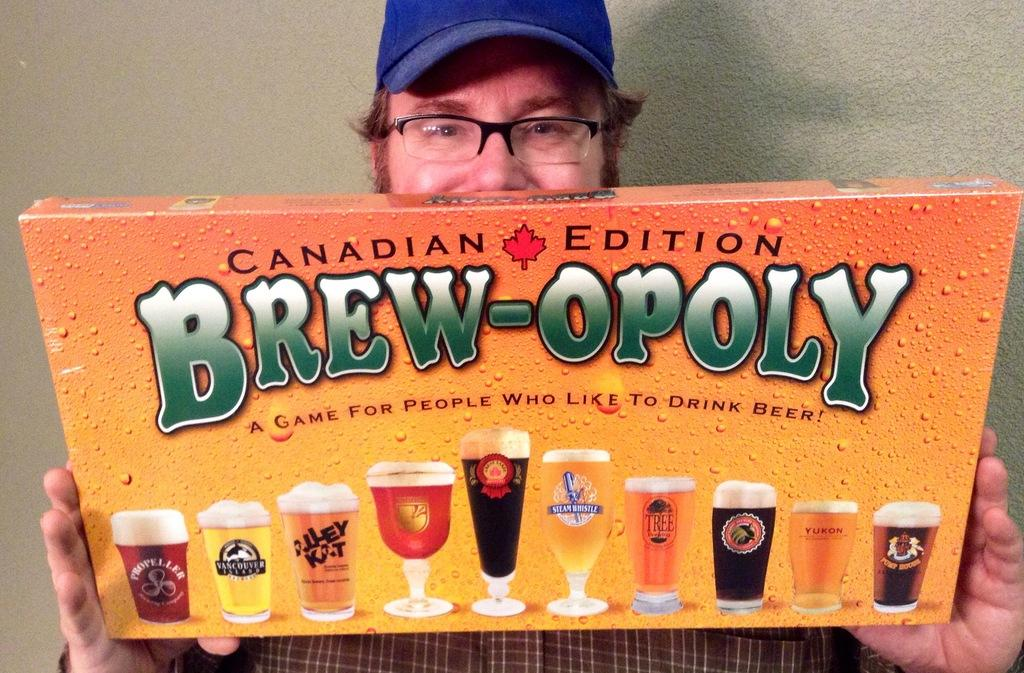<image>
Describe the image concisely. A man holding a Canadian Edition of Brew-Opoly. 